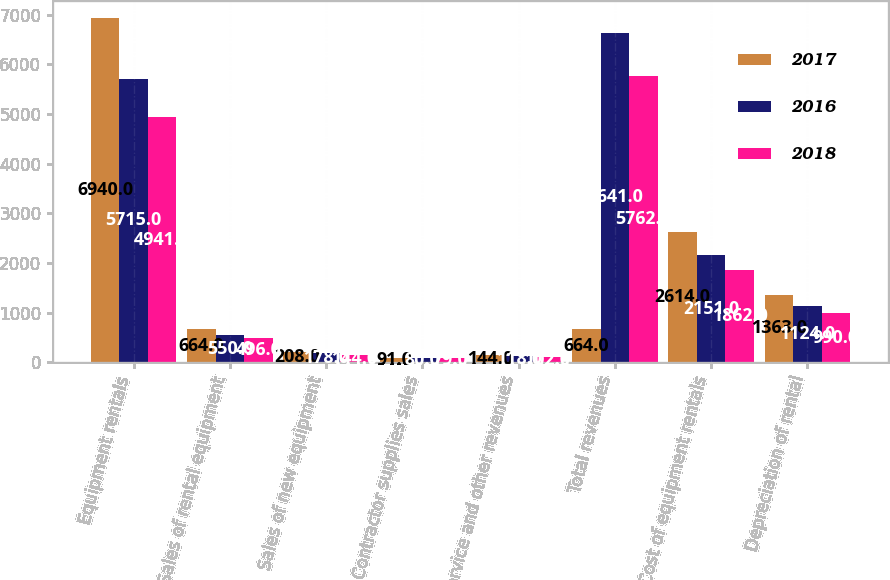Convert chart to OTSL. <chart><loc_0><loc_0><loc_500><loc_500><stacked_bar_chart><ecel><fcel>Equipment rentals<fcel>Sales of rental equipment<fcel>Sales of new equipment<fcel>Contractor supplies sales<fcel>Service and other revenues<fcel>Total revenues<fcel>Cost of equipment rentals<fcel>Depreciation of rental<nl><fcel>2017<fcel>6940<fcel>664<fcel>208<fcel>91<fcel>144<fcel>664<fcel>2614<fcel>1363<nl><fcel>2016<fcel>5715<fcel>550<fcel>178<fcel>80<fcel>118<fcel>6641<fcel>2151<fcel>1124<nl><fcel>2018<fcel>4941<fcel>496<fcel>144<fcel>79<fcel>102<fcel>5762<fcel>1862<fcel>990<nl></chart> 